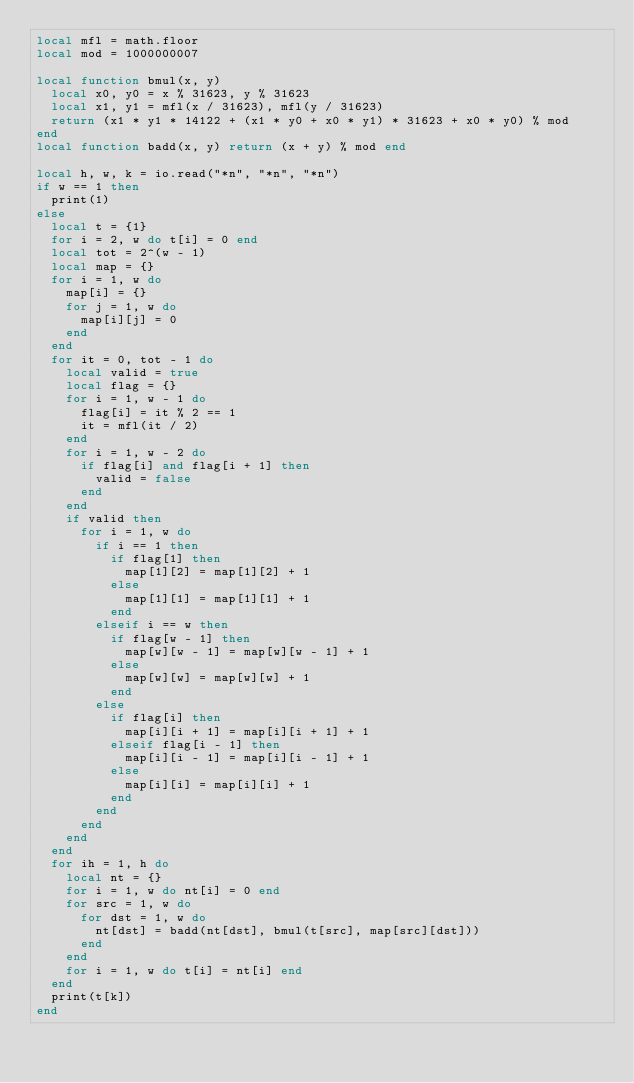<code> <loc_0><loc_0><loc_500><loc_500><_Lua_>local mfl = math.floor
local mod = 1000000007

local function bmul(x, y)
  local x0, y0 = x % 31623, y % 31623
  local x1, y1 = mfl(x / 31623), mfl(y / 31623)
  return (x1 * y1 * 14122 + (x1 * y0 + x0 * y1) * 31623 + x0 * y0) % mod
end
local function badd(x, y) return (x + y) % mod end

local h, w, k = io.read("*n", "*n", "*n")
if w == 1 then
  print(1)
else
  local t = {1}
  for i = 2, w do t[i] = 0 end
  local tot = 2^(w - 1)
  local map = {}
  for i = 1, w do
    map[i] = {}
    for j = 1, w do
      map[i][j] = 0
    end
  end
  for it = 0, tot - 1 do
    local valid = true
    local flag = {}
    for i = 1, w - 1 do
      flag[i] = it % 2 == 1
      it = mfl(it / 2)
    end
    for i = 1, w - 2 do
      if flag[i] and flag[i + 1] then
        valid = false
      end
    end
    if valid then
      for i = 1, w do
        if i == 1 then
          if flag[1] then
            map[1][2] = map[1][2] + 1
          else
            map[1][1] = map[1][1] + 1
          end
        elseif i == w then
          if flag[w - 1] then
            map[w][w - 1] = map[w][w - 1] + 1
          else
            map[w][w] = map[w][w] + 1
          end
        else
          if flag[i] then
            map[i][i + 1] = map[i][i + 1] + 1
          elseif flag[i - 1] then
            map[i][i - 1] = map[i][i - 1] + 1
          else
            map[i][i] = map[i][i] + 1
          end
        end
      end
    end
  end
  for ih = 1, h do
    local nt = {}
    for i = 1, w do nt[i] = 0 end
    for src = 1, w do
      for dst = 1, w do
        nt[dst] = badd(nt[dst], bmul(t[src], map[src][dst]))
      end
    end
    for i = 1, w do t[i] = nt[i] end
  end
  print(t[k])
end
</code> 